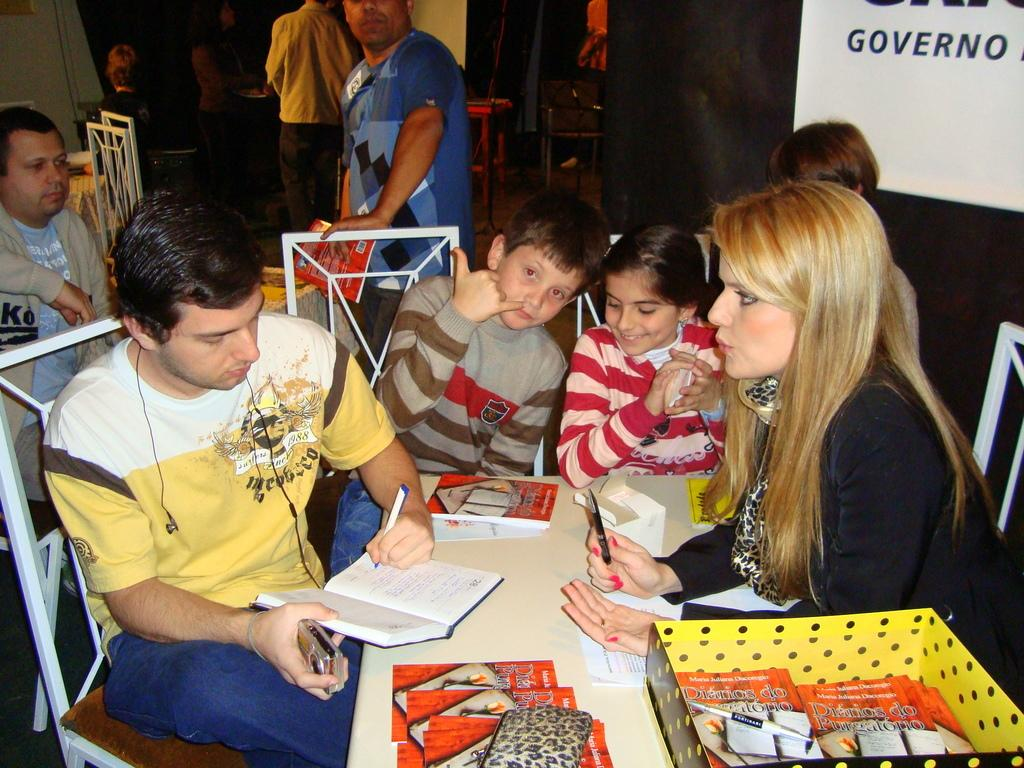Provide a one-sentence caption for the provided image. The person signing books is called Maria Juliana Dacorego. 